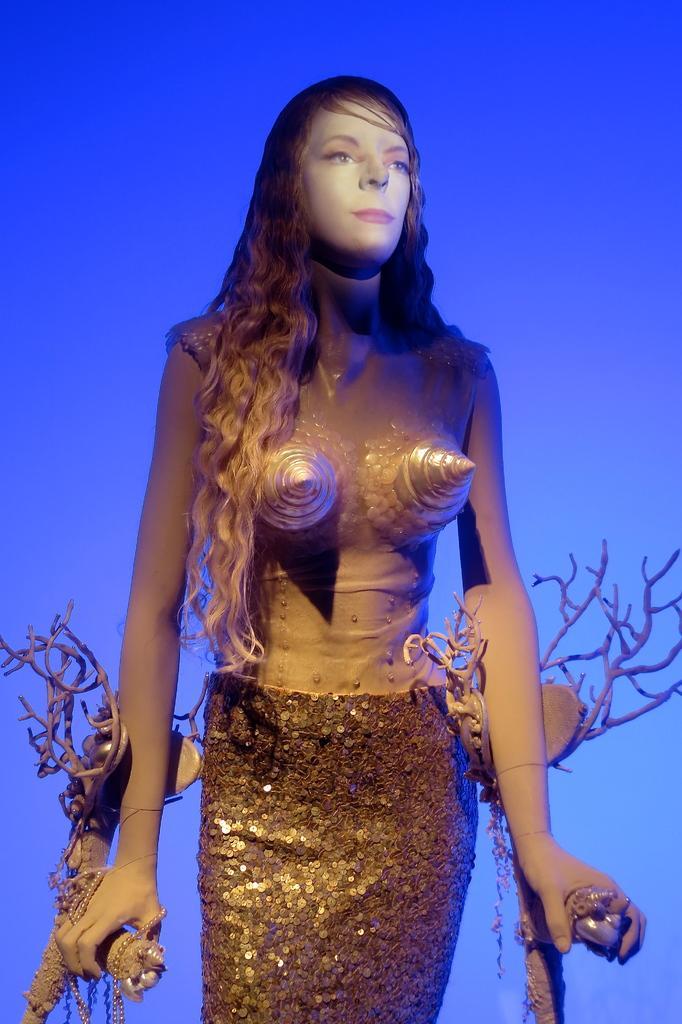Could you give a brief overview of what you see in this image? In the image we can see a woman standing and wearing clothes. The background is blue in color and this is a chain. 